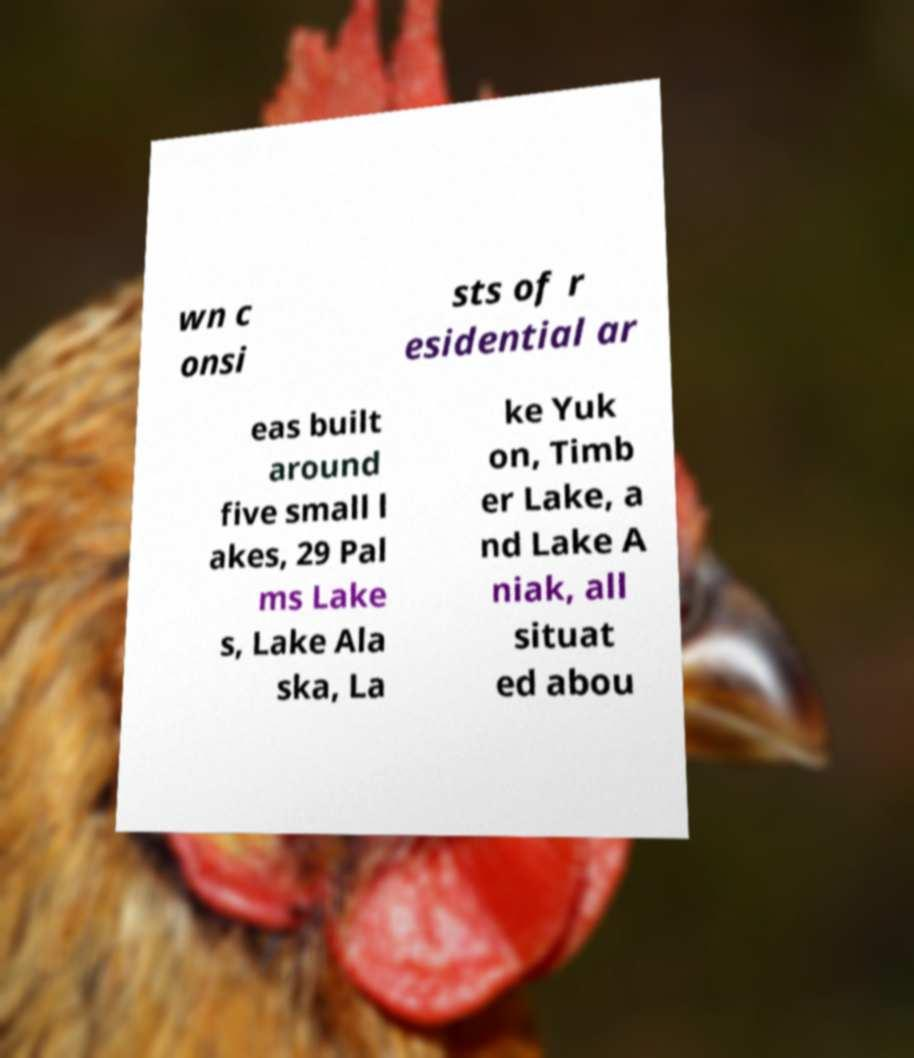Could you assist in decoding the text presented in this image and type it out clearly? wn c onsi sts of r esidential ar eas built around five small l akes, 29 Pal ms Lake s, Lake Ala ska, La ke Yuk on, Timb er Lake, a nd Lake A niak, all situat ed abou 